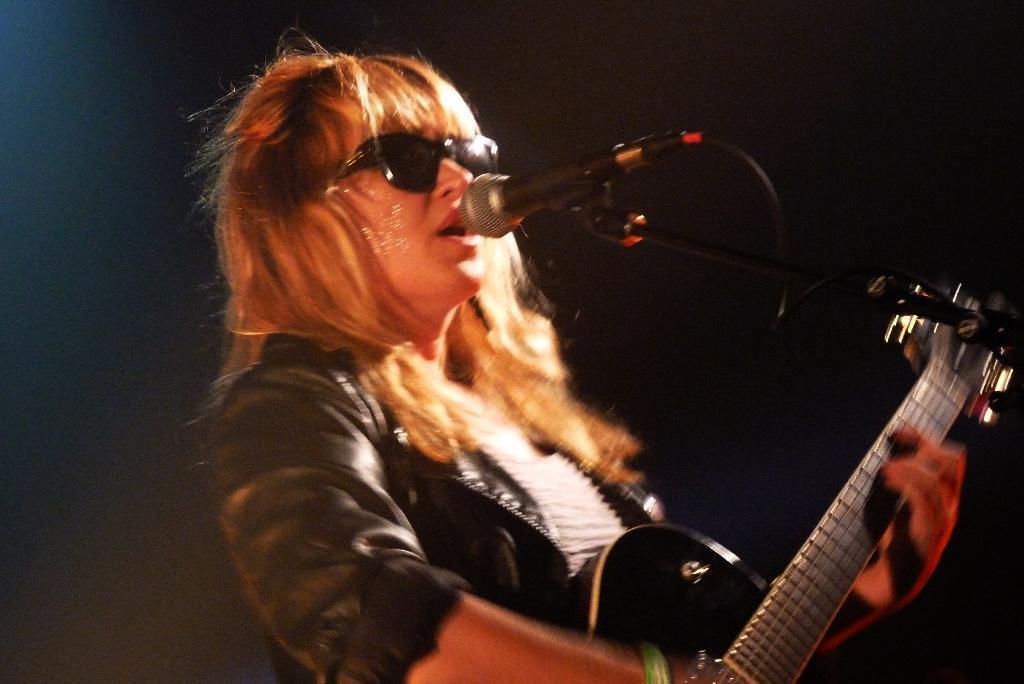How would you summarize this image in a sentence or two? In this image we can see person holding guitar and speaking to the mic. 